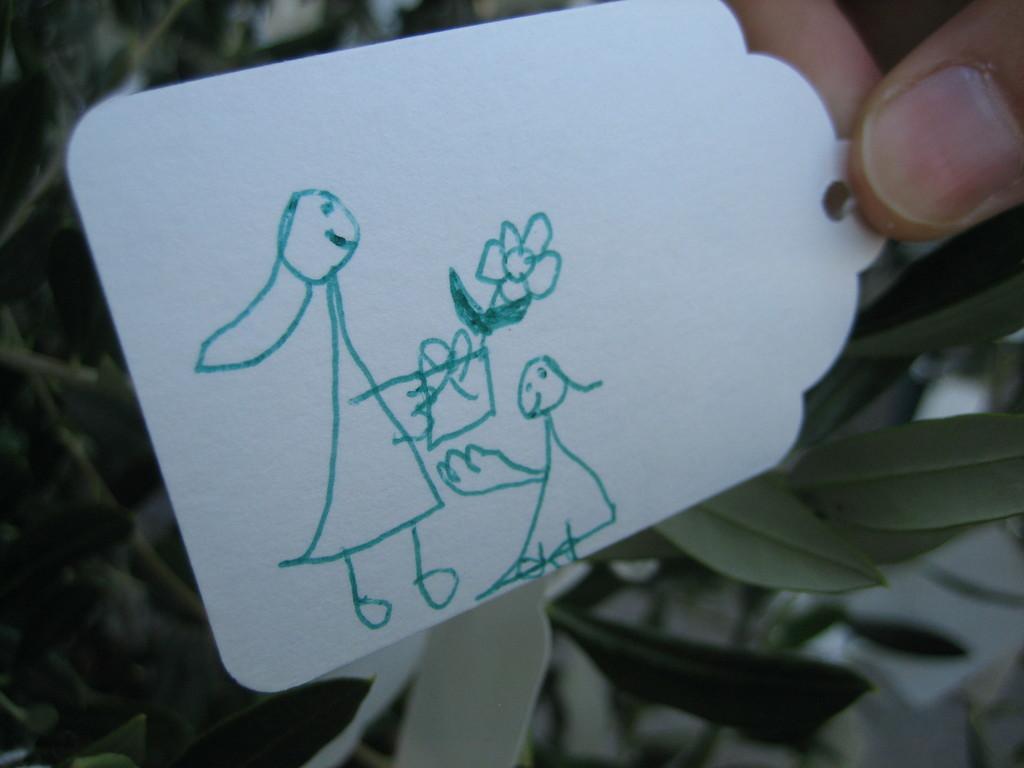Could you give a brief overview of what you see in this image? In this image we can see a picture drawn on the tag and a person holding it. In the background we can see leaves. 